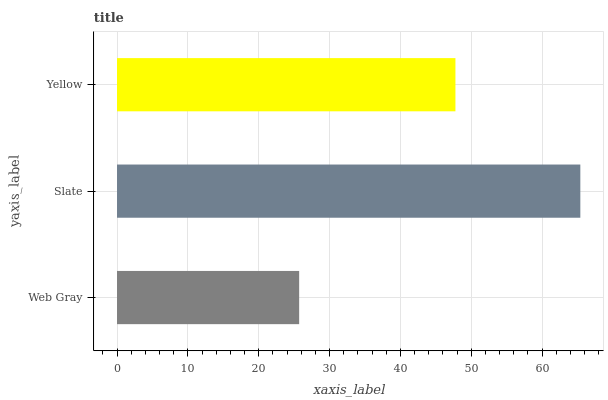Is Web Gray the minimum?
Answer yes or no. Yes. Is Slate the maximum?
Answer yes or no. Yes. Is Yellow the minimum?
Answer yes or no. No. Is Yellow the maximum?
Answer yes or no. No. Is Slate greater than Yellow?
Answer yes or no. Yes. Is Yellow less than Slate?
Answer yes or no. Yes. Is Yellow greater than Slate?
Answer yes or no. No. Is Slate less than Yellow?
Answer yes or no. No. Is Yellow the high median?
Answer yes or no. Yes. Is Yellow the low median?
Answer yes or no. Yes. Is Web Gray the high median?
Answer yes or no. No. Is Web Gray the low median?
Answer yes or no. No. 